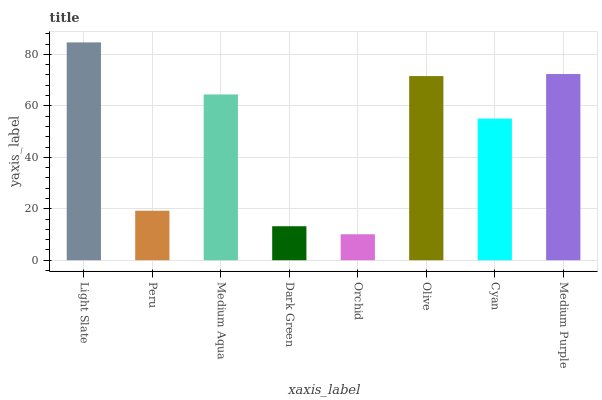Is Orchid the minimum?
Answer yes or no. Yes. Is Light Slate the maximum?
Answer yes or no. Yes. Is Peru the minimum?
Answer yes or no. No. Is Peru the maximum?
Answer yes or no. No. Is Light Slate greater than Peru?
Answer yes or no. Yes. Is Peru less than Light Slate?
Answer yes or no. Yes. Is Peru greater than Light Slate?
Answer yes or no. No. Is Light Slate less than Peru?
Answer yes or no. No. Is Medium Aqua the high median?
Answer yes or no. Yes. Is Cyan the low median?
Answer yes or no. Yes. Is Cyan the high median?
Answer yes or no. No. Is Olive the low median?
Answer yes or no. No. 